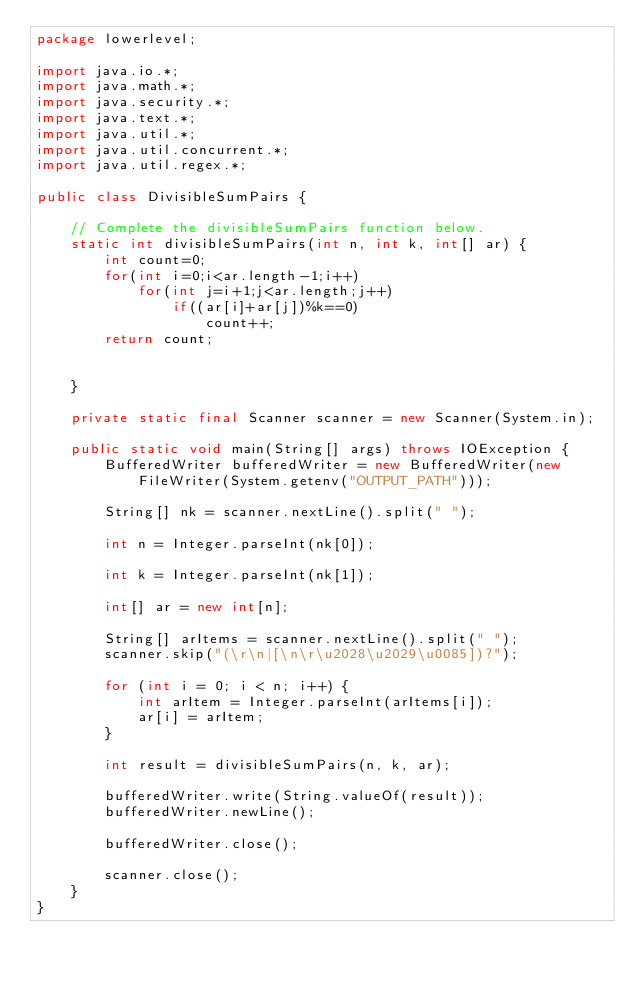Convert code to text. <code><loc_0><loc_0><loc_500><loc_500><_Java_>package lowerlevel;

import java.io.*;
import java.math.*;
import java.security.*;
import java.text.*;
import java.util.*;
import java.util.concurrent.*;
import java.util.regex.*;

public class DivisibleSumPairs {

    // Complete the divisibleSumPairs function below.
    static int divisibleSumPairs(int n, int k, int[] ar) {
    	int count=0;
    	for(int i=0;i<ar.length-1;i++)
    		for(int j=i+1;j<ar.length;j++)
    			if((ar[i]+ar[j])%k==0)
    				count++;
    	return count;
    			

    }

    private static final Scanner scanner = new Scanner(System.in);

    public static void main(String[] args) throws IOException {
        BufferedWriter bufferedWriter = new BufferedWriter(new FileWriter(System.getenv("OUTPUT_PATH")));

        String[] nk = scanner.nextLine().split(" ");

        int n = Integer.parseInt(nk[0]);

        int k = Integer.parseInt(nk[1]);

        int[] ar = new int[n];

        String[] arItems = scanner.nextLine().split(" ");
        scanner.skip("(\r\n|[\n\r\u2028\u2029\u0085])?");

        for (int i = 0; i < n; i++) {
            int arItem = Integer.parseInt(arItems[i]);
            ar[i] = arItem;
        }

        int result = divisibleSumPairs(n, k, ar);

        bufferedWriter.write(String.valueOf(result));
        bufferedWriter.newLine();

        bufferedWriter.close();

        scanner.close();
    }
}
</code> 